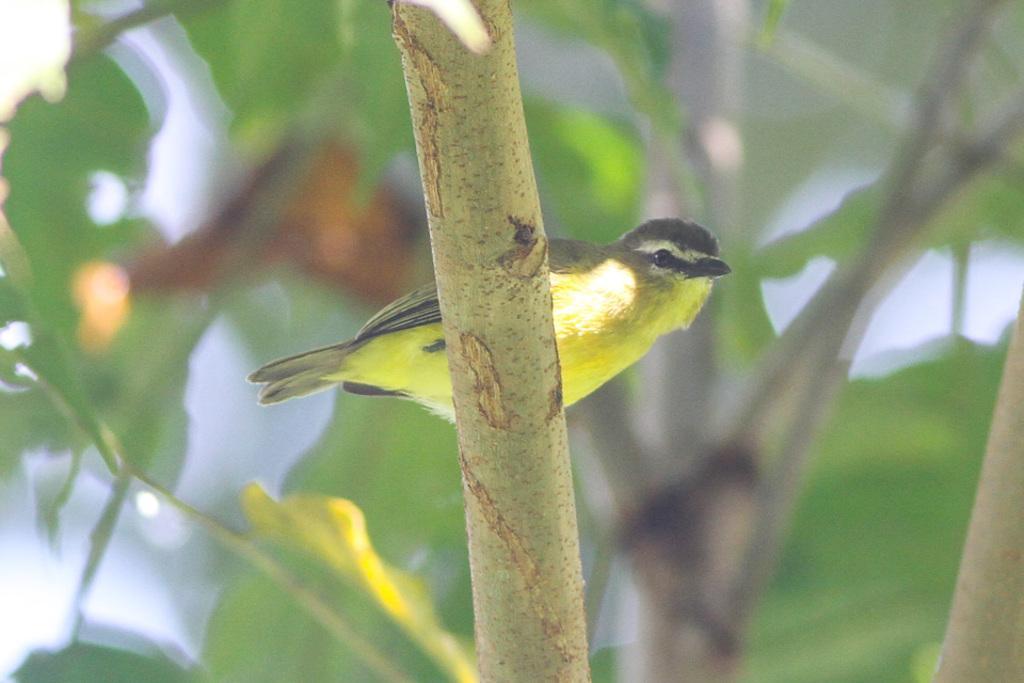Could you give a brief overview of what you see in this image? In the image in the center, we can see one branch. On the branch, we can see one bird, which is in green and black color. In the there is a tree. 